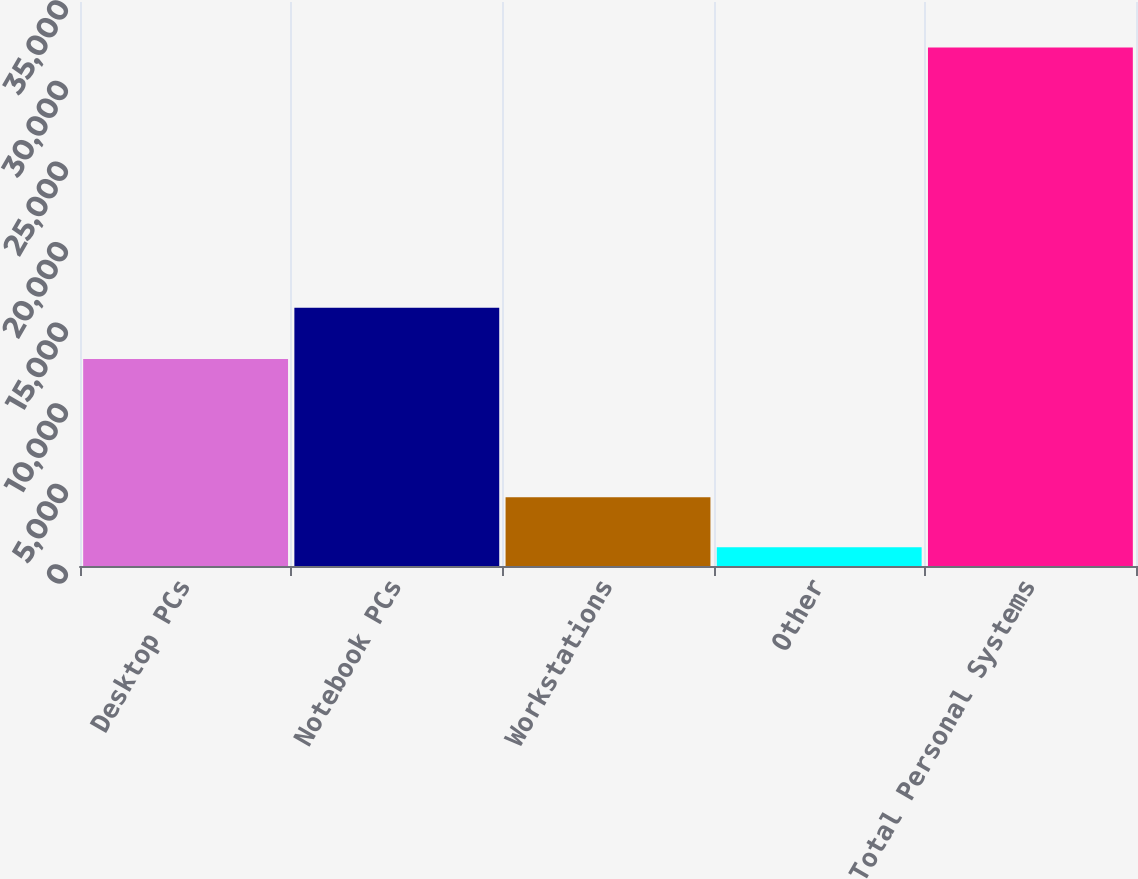Convert chart to OTSL. <chart><loc_0><loc_0><loc_500><loc_500><bar_chart><fcel>Desktop PCs<fcel>Notebook PCs<fcel>Workstations<fcel>Other<fcel>Total Personal Systems<nl><fcel>12844<fcel>16029<fcel>4261<fcel>1159<fcel>32179<nl></chart> 